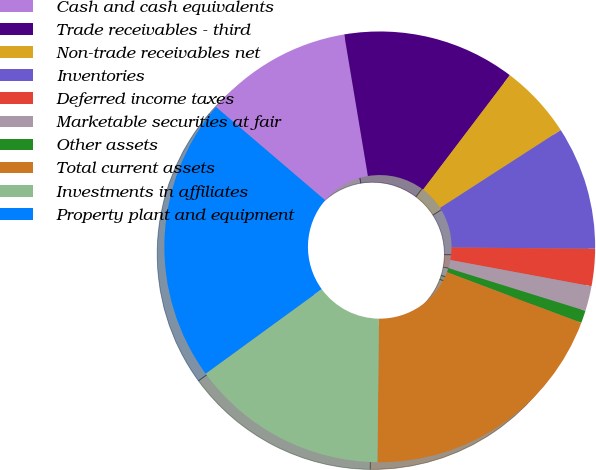Convert chart. <chart><loc_0><loc_0><loc_500><loc_500><pie_chart><fcel>Cash and cash equivalents<fcel>Trade receivables - third<fcel>Non-trade receivables net<fcel>Inventories<fcel>Deferred income taxes<fcel>Marketable securities at fair<fcel>Other assets<fcel>Total current assets<fcel>Investments in affiliates<fcel>Property plant and equipment<nl><fcel>11.11%<fcel>12.96%<fcel>5.56%<fcel>9.26%<fcel>2.79%<fcel>1.87%<fcel>0.94%<fcel>19.43%<fcel>14.81%<fcel>21.27%<nl></chart> 